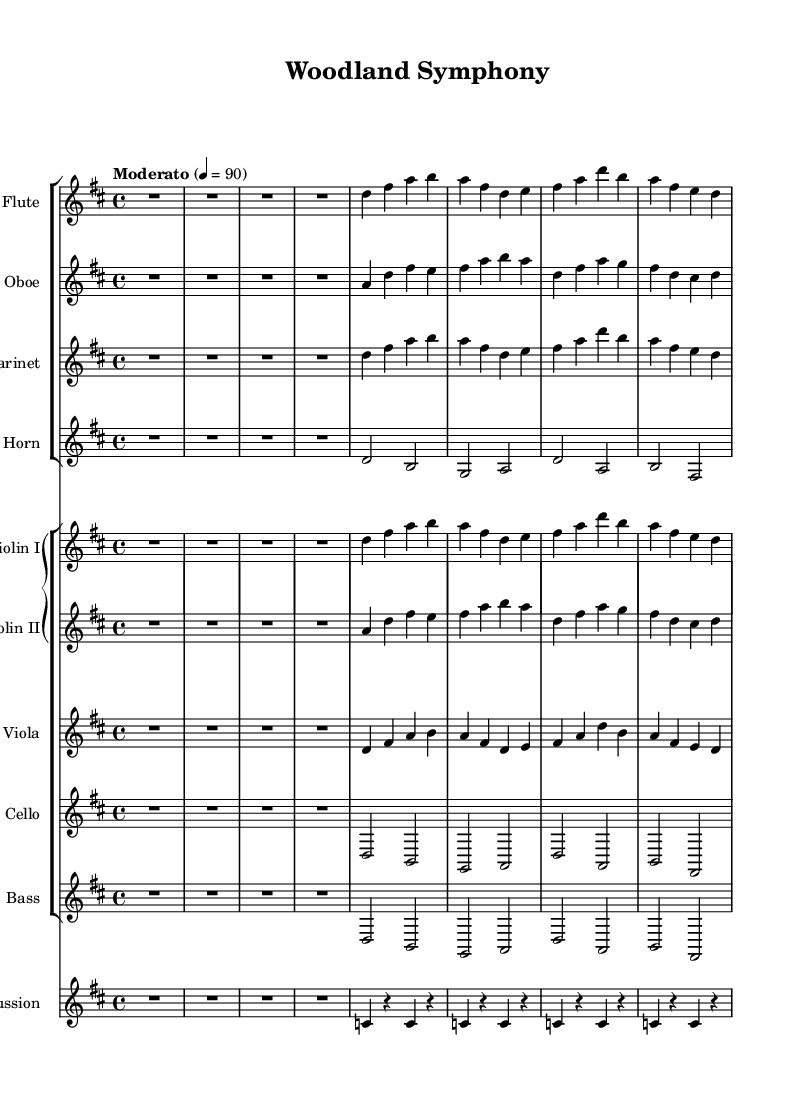What is the key signature of this music? The key signature is indicated by the sharp notes found in the music. For this piece, there are two sharps, which corresponds to D major.
Answer: D major What is the time signature of this composition? The time signature is located at the beginning of the score. In this case, it is indicated as 4/4.
Answer: 4/4 What is the tempo marking of the piece? The tempo marking is found near the beginning of the score. It states "Moderato" and the speed is defined as 4 = 90.
Answer: Moderato Which instruments are featured in the first staff group? By looking at the staff group section of the score, the instruments listed are Flute, Oboe, Clarinet, and Horn.
Answer: Flute, Oboe, Clarinet, Horn How many notes are played in the first measure of the violin I part? The first measure of the violin I part contains four notes: D, F#, A, B. Counting these notes confirms there are four.
Answer: 4 Which instrument plays a sustained note in the second measure of the cello part? The second measure of the cello part shows that a half note, which is sustained, is played on D. It stays for two beats.
Answer: Cello What is the role of the percussion in this composition? The percussion measures show repeated quarter note patterns, supporting the rhythm and adding a biophonic texture to the overall sound, resembling natural elements.
Answer: Supportive rhythm 